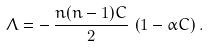Convert formula to latex. <formula><loc_0><loc_0><loc_500><loc_500>\Lambda = - \, \frac { n ( n - 1 ) C } { 2 } \, \left ( 1 - \alpha C \right ) .</formula> 